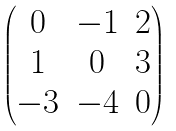<formula> <loc_0><loc_0><loc_500><loc_500>\begin{pmatrix} 0 & - 1 & 2 \\ 1 & 0 & 3 \\ - 3 & - 4 & 0 \end{pmatrix}</formula> 